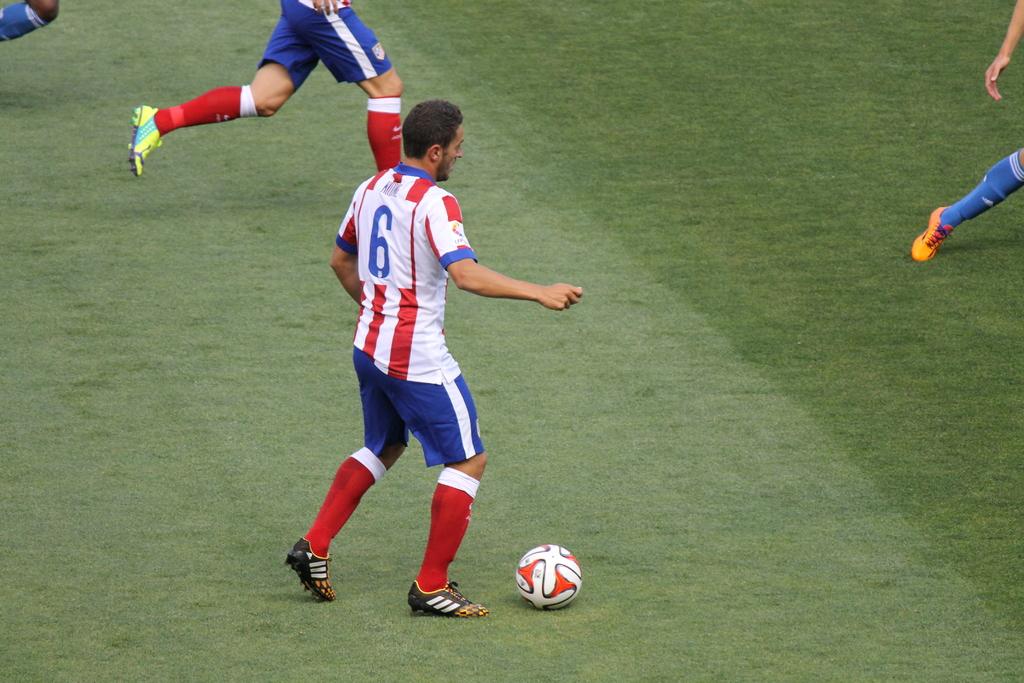What is this soccor players jersey number?
Your response must be concise. 6. 